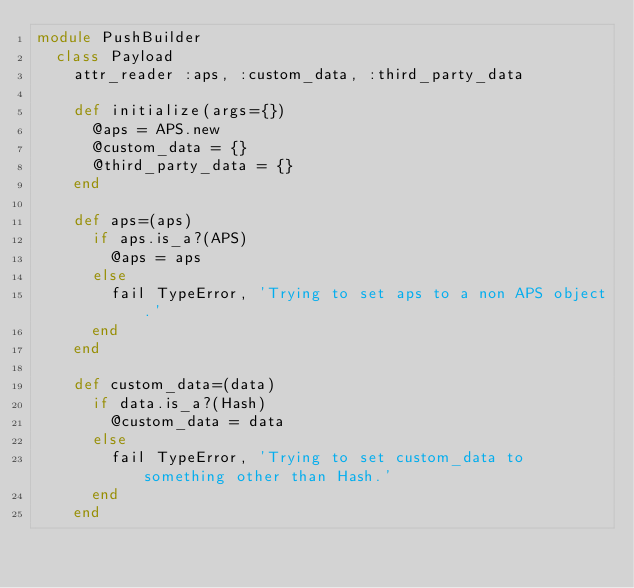<code> <loc_0><loc_0><loc_500><loc_500><_Ruby_>module PushBuilder
  class Payload
    attr_reader :aps, :custom_data, :third_party_data

    def initialize(args={})
      @aps = APS.new
      @custom_data = {}
      @third_party_data = {}
    end

    def aps=(aps)
      if aps.is_a?(APS)
        @aps = aps
      else
        fail TypeError, 'Trying to set aps to a non APS object.'
      end
    end

    def custom_data=(data)
      if data.is_a?(Hash)
        @custom_data = data
      else
        fail TypeError, 'Trying to set custom_data to something other than Hash.'
      end
    end
</code> 